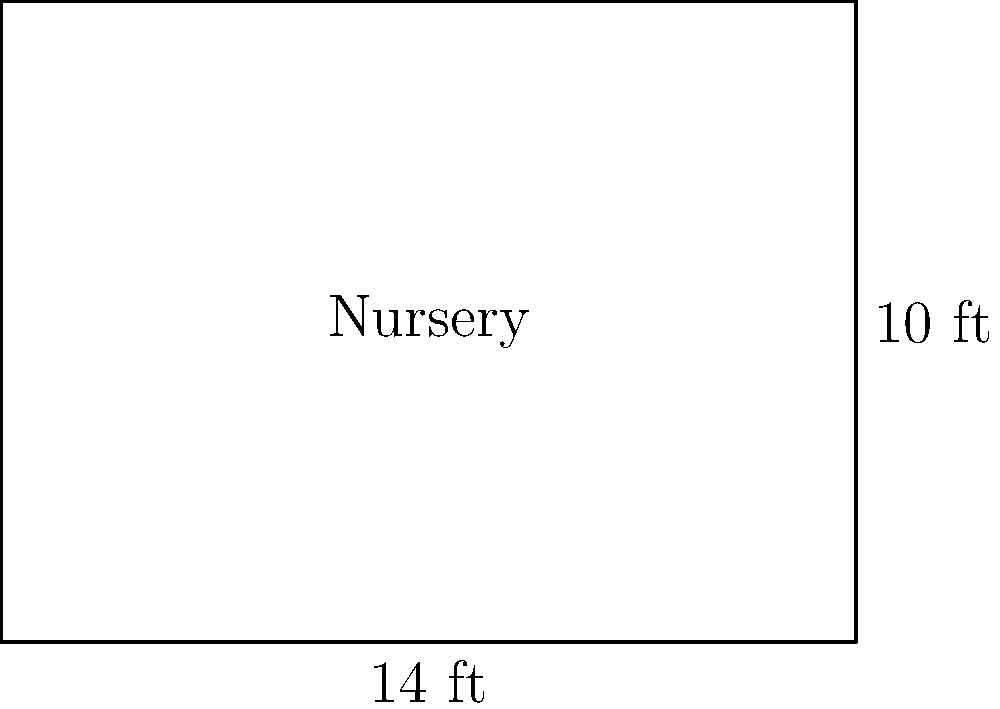You're planning to decorate your baby's nursery. The room is rectangular, measuring 14 feet in length and 10 feet in width. What is the total floor area of the nursery in square feet? To find the area of a rectangular room, we need to multiply its length by its width. Let's follow these steps:

1. Identify the given dimensions:
   - Length = 14 feet
   - Width = 10 feet

2. Use the formula for the area of a rectangle:
   $$ \text{Area} = \text{Length} \times \text{Width} $$

3. Substitute the values into the formula:
   $$ \text{Area} = 14 \text{ ft} \times 10 \text{ ft} $$

4. Perform the multiplication:
   $$ \text{Area} = 140 \text{ ft}^2 $$

Therefore, the total floor area of the nursery is 140 square feet.
Answer: 140 ft² 